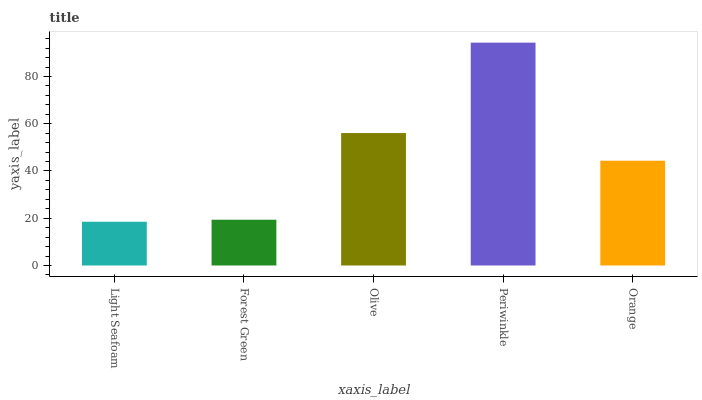Is Light Seafoam the minimum?
Answer yes or no. Yes. Is Periwinkle the maximum?
Answer yes or no. Yes. Is Forest Green the minimum?
Answer yes or no. No. Is Forest Green the maximum?
Answer yes or no. No. Is Forest Green greater than Light Seafoam?
Answer yes or no. Yes. Is Light Seafoam less than Forest Green?
Answer yes or no. Yes. Is Light Seafoam greater than Forest Green?
Answer yes or no. No. Is Forest Green less than Light Seafoam?
Answer yes or no. No. Is Orange the high median?
Answer yes or no. Yes. Is Orange the low median?
Answer yes or no. Yes. Is Light Seafoam the high median?
Answer yes or no. No. Is Periwinkle the low median?
Answer yes or no. No. 